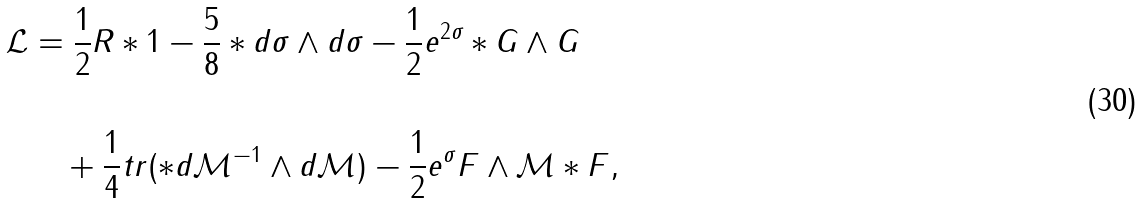Convert formula to latex. <formula><loc_0><loc_0><loc_500><loc_500>\mathcal { L } & = \frac { 1 } { 2 } R \ast 1 - \frac { 5 } { 8 } \ast d \sigma \wedge d \sigma - \frac { 1 } { 2 } e ^ { 2 \sigma } \ast G \wedge G \\ \\ & \quad + \frac { 1 } { 4 } t r ( \ast d \mathcal { M } ^ { - 1 } \wedge d \mathcal { M } ) - \frac { 1 } { 2 } e ^ { \sigma } F \wedge \mathcal { M } \ast F ,</formula> 